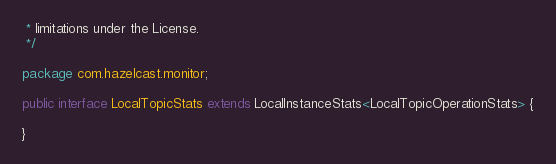<code> <loc_0><loc_0><loc_500><loc_500><_Java_> * limitations under the License.
 */

package com.hazelcast.monitor;

public interface LocalTopicStats extends LocalInstanceStats<LocalTopicOperationStats> {

}
</code> 